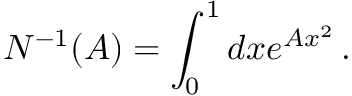Convert formula to latex. <formula><loc_0><loc_0><loc_500><loc_500>N ^ { - 1 } ( A ) = \int _ { 0 } ^ { 1 } d x e ^ { A x ^ { 2 } } \, .</formula> 